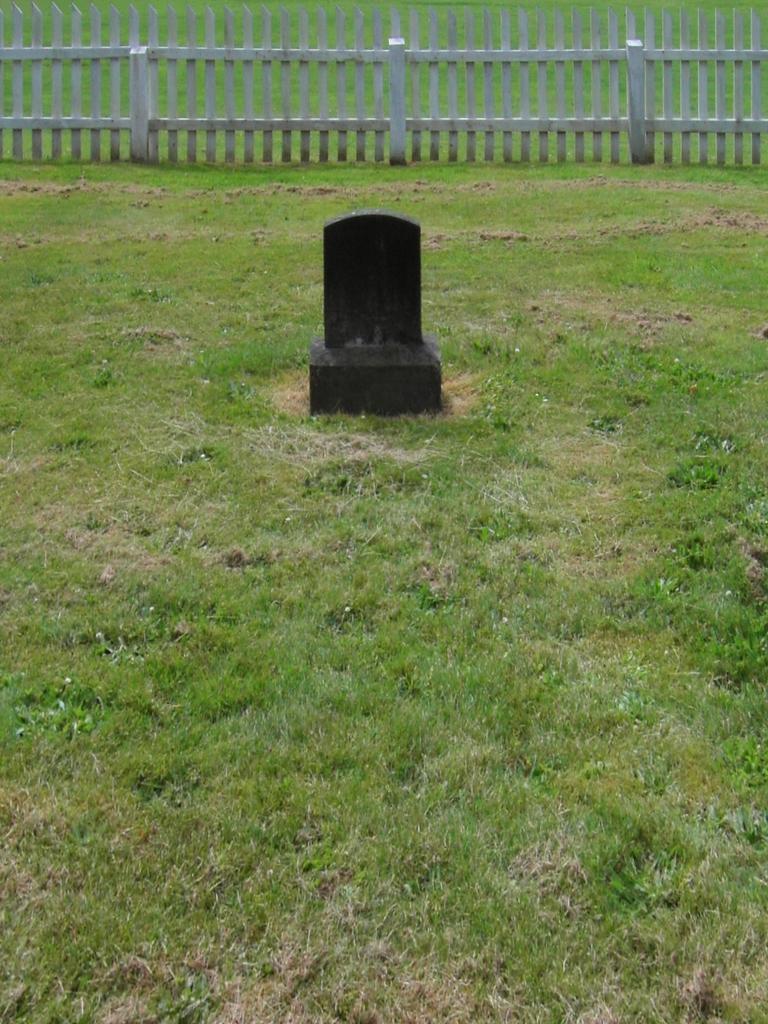Please provide a concise description of this image. In the foreground of this image, it seems like a head stone on the grass and at the top, there is wooden fencing. 